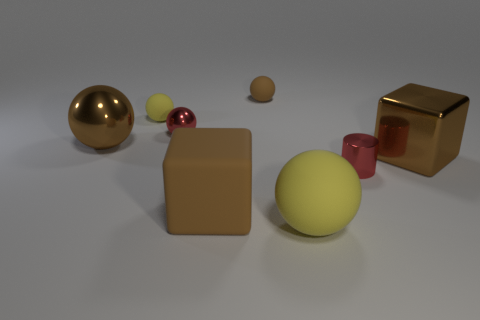There is a yellow thing that is the same size as the cylinder; what is it made of?
Make the answer very short. Rubber. Is the number of small brown things right of the tiny red shiny cylinder less than the number of small objects to the left of the tiny red sphere?
Your answer should be compact. Yes. There is a brown metallic object to the left of the big matte object that is to the left of the big yellow sphere; what is its shape?
Your response must be concise. Sphere. Are there any small yellow cylinders?
Ensure brevity in your answer.  No. There is a block that is on the left side of the tiny red metal cylinder; what color is it?
Your answer should be very brief. Brown. What material is the other sphere that is the same color as the big rubber sphere?
Provide a short and direct response. Rubber. There is a red shiny ball; are there any big brown spheres on the right side of it?
Keep it short and to the point. No. Are there more large metal objects than large metallic blocks?
Offer a terse response. Yes. There is a small sphere on the left side of the shiny sphere behind the brown sphere to the left of the brown rubber sphere; what is its color?
Give a very brief answer. Yellow. There is a big block that is made of the same material as the small yellow object; what color is it?
Ensure brevity in your answer.  Brown. 